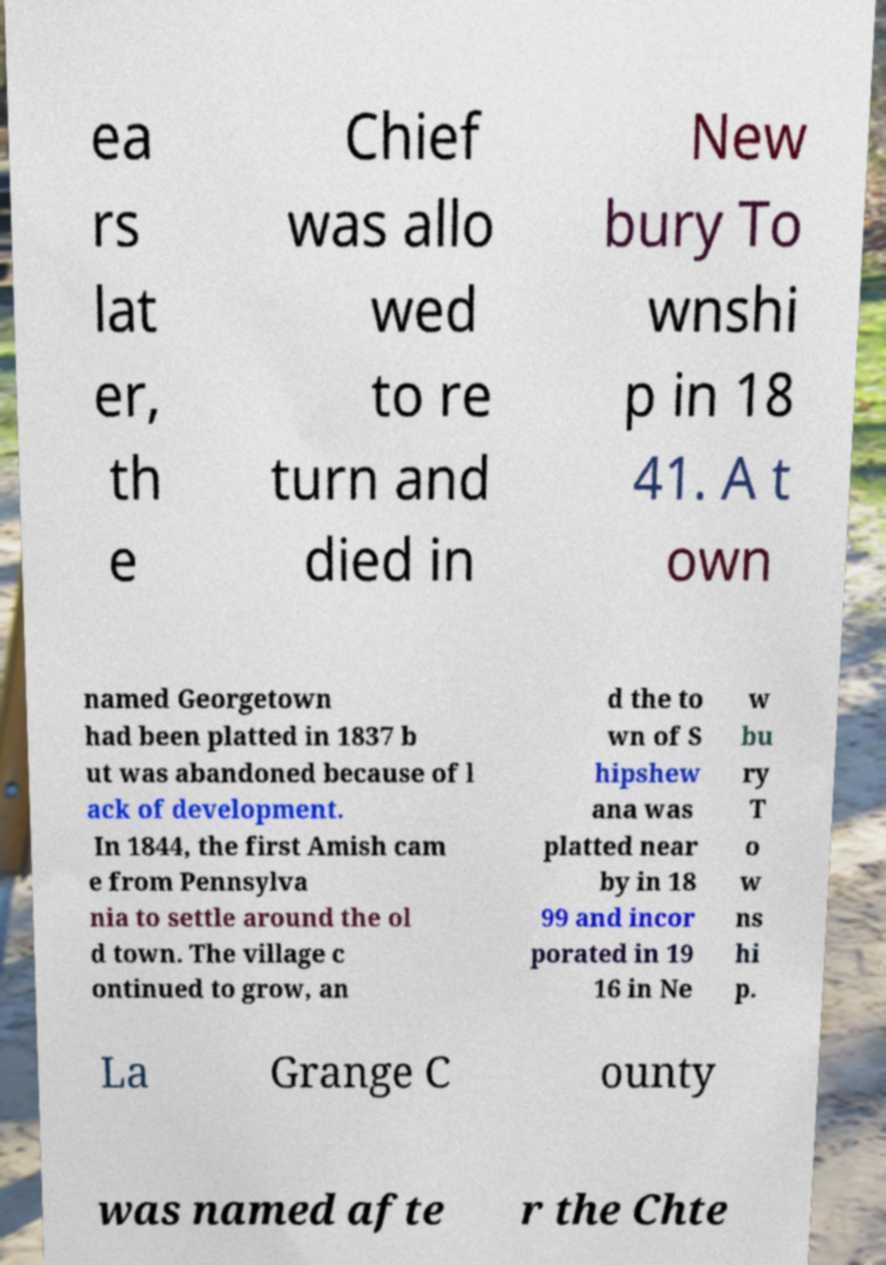For documentation purposes, I need the text within this image transcribed. Could you provide that? ea rs lat er, th e Chief was allo wed to re turn and died in New bury To wnshi p in 18 41. A t own named Georgetown had been platted in 1837 b ut was abandoned because of l ack of development. In 1844, the first Amish cam e from Pennsylva nia to settle around the ol d town. The village c ontinued to grow, an d the to wn of S hipshew ana was platted near by in 18 99 and incor porated in 19 16 in Ne w bu ry T o w ns hi p. La Grange C ounty was named afte r the Chte 